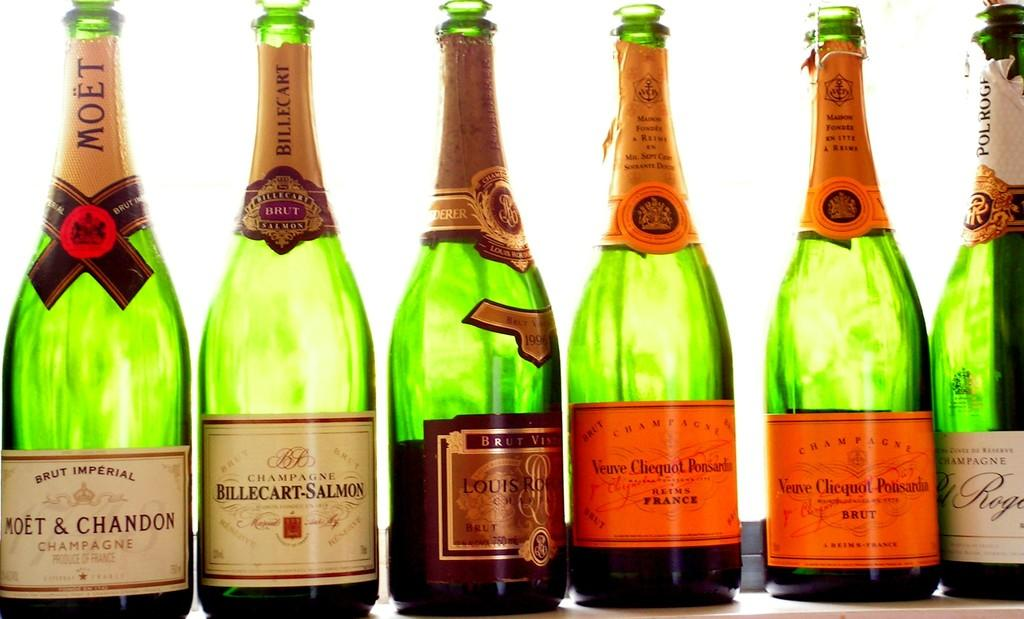<image>
Create a compact narrative representing the image presented. the word champagne is on the glass item 